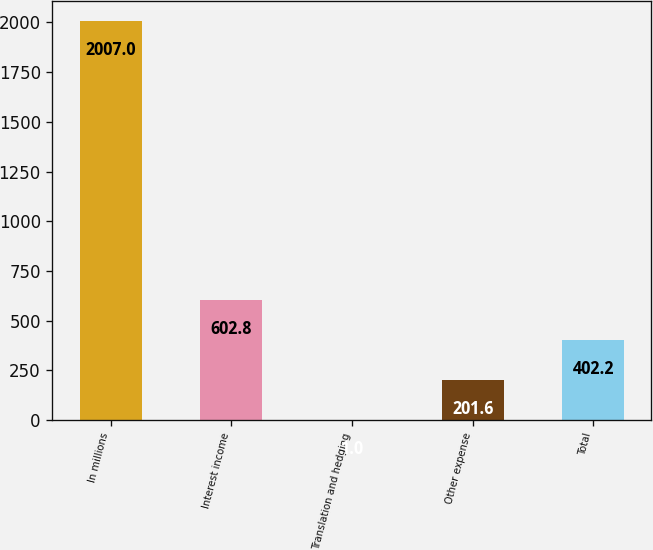Convert chart. <chart><loc_0><loc_0><loc_500><loc_500><bar_chart><fcel>In millions<fcel>Interest income<fcel>Translation and hedging<fcel>Other expense<fcel>Total<nl><fcel>2007<fcel>602.8<fcel>1<fcel>201.6<fcel>402.2<nl></chart> 